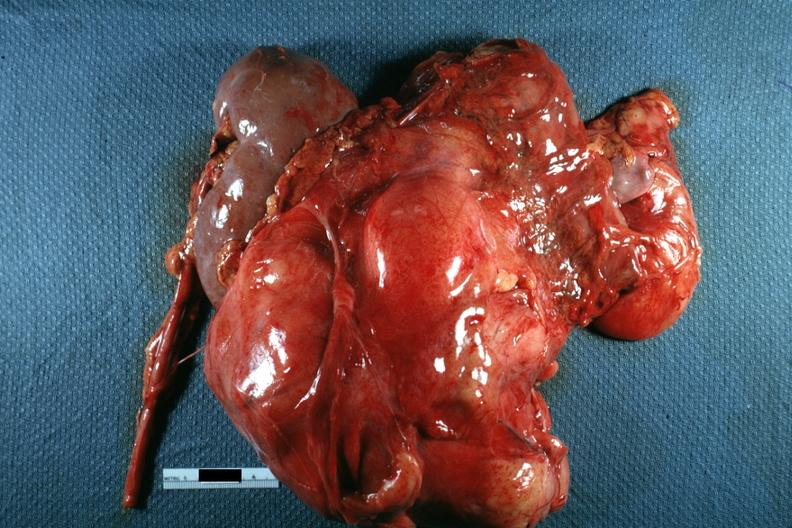what is nodular mass with kidney seen?
Answer the question using a single word or phrase. On one side photo of little use without showing cut surface 